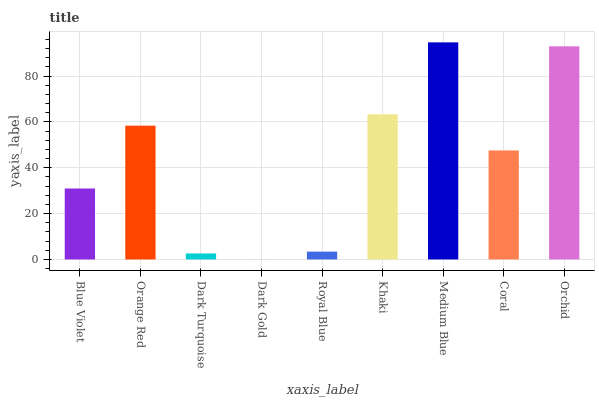Is Dark Gold the minimum?
Answer yes or no. Yes. Is Medium Blue the maximum?
Answer yes or no. Yes. Is Orange Red the minimum?
Answer yes or no. No. Is Orange Red the maximum?
Answer yes or no. No. Is Orange Red greater than Blue Violet?
Answer yes or no. Yes. Is Blue Violet less than Orange Red?
Answer yes or no. Yes. Is Blue Violet greater than Orange Red?
Answer yes or no. No. Is Orange Red less than Blue Violet?
Answer yes or no. No. Is Coral the high median?
Answer yes or no. Yes. Is Coral the low median?
Answer yes or no. Yes. Is Orchid the high median?
Answer yes or no. No. Is Orchid the low median?
Answer yes or no. No. 